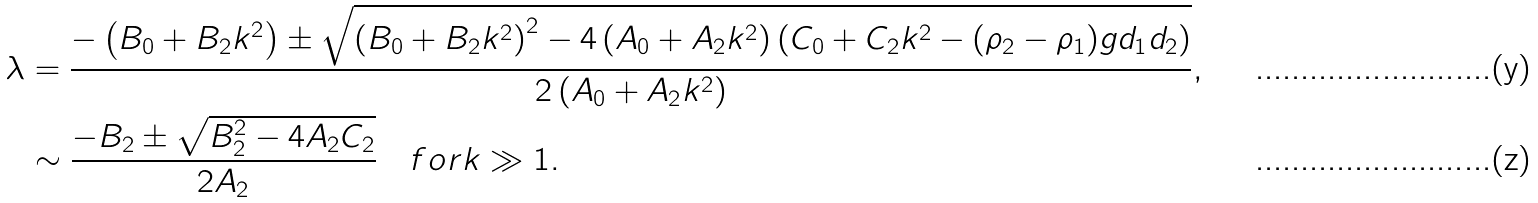Convert formula to latex. <formula><loc_0><loc_0><loc_500><loc_500>\lambda & = \frac { - \left ( B _ { 0 } + B _ { 2 } k ^ { 2 } \right ) \pm \sqrt { \left ( B _ { 0 } + B _ { 2 } k ^ { 2 } \right ) ^ { 2 } - 4 \left ( A _ { 0 } + A _ { 2 } k ^ { 2 } \right ) \left ( C _ { 0 } + C _ { 2 } k ^ { 2 } - ( \rho _ { 2 } - \rho _ { 1 } ) g d _ { 1 } d _ { 2 } \right ) } } { 2 \left ( A _ { 0 } + A _ { 2 } k ^ { 2 } \right ) } , \\ & \sim \frac { - B _ { 2 } \pm \sqrt { B _ { 2 } ^ { 2 } - 4 A _ { 2 } C _ { 2 } } } { 2 A _ { 2 } } \quad f o r k \gg 1 .</formula> 